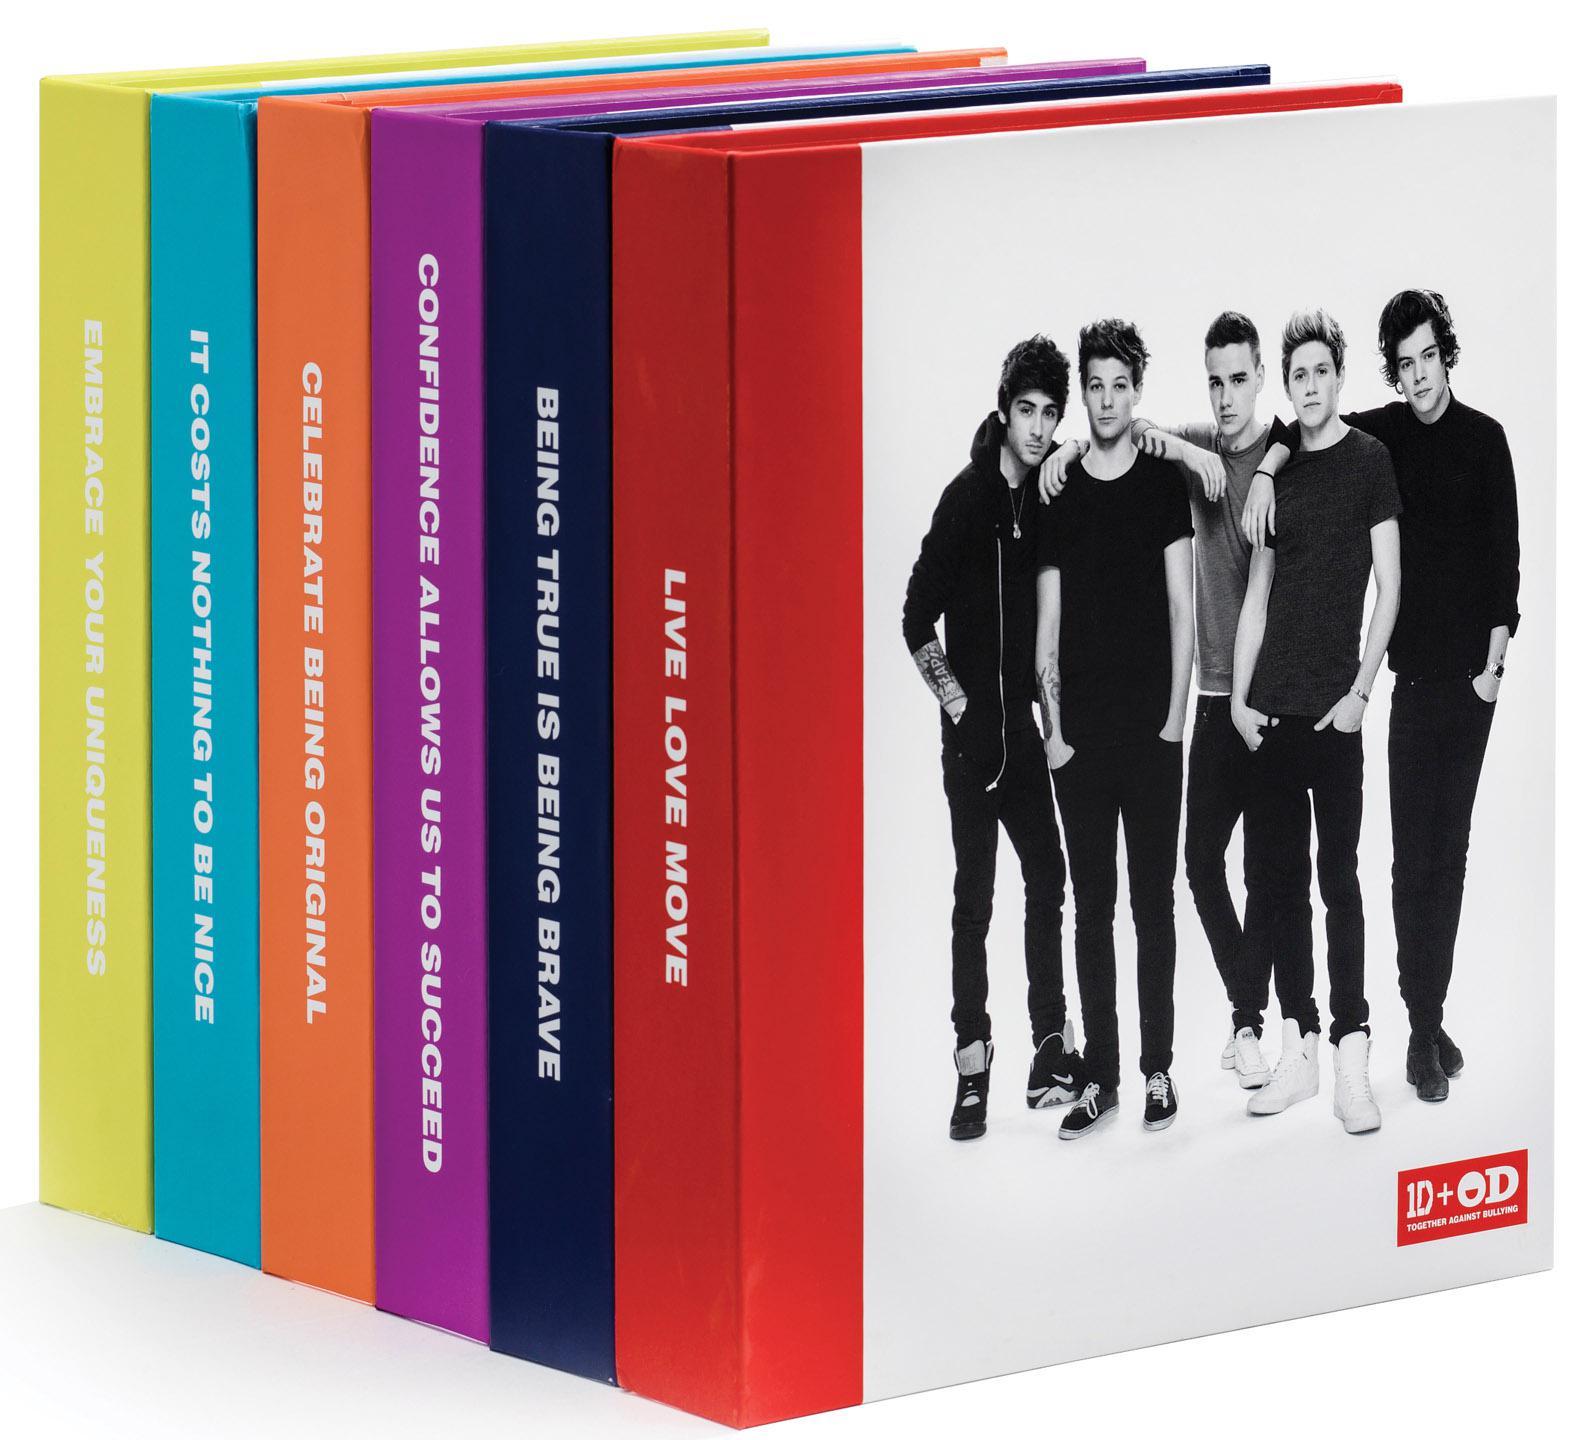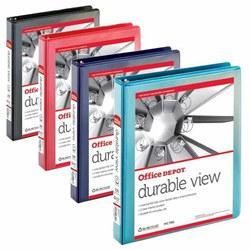The first image is the image on the left, the second image is the image on the right. Analyze the images presented: Is the assertion "The right image image depicts no more than three binders." valid? Answer yes or no. No. 